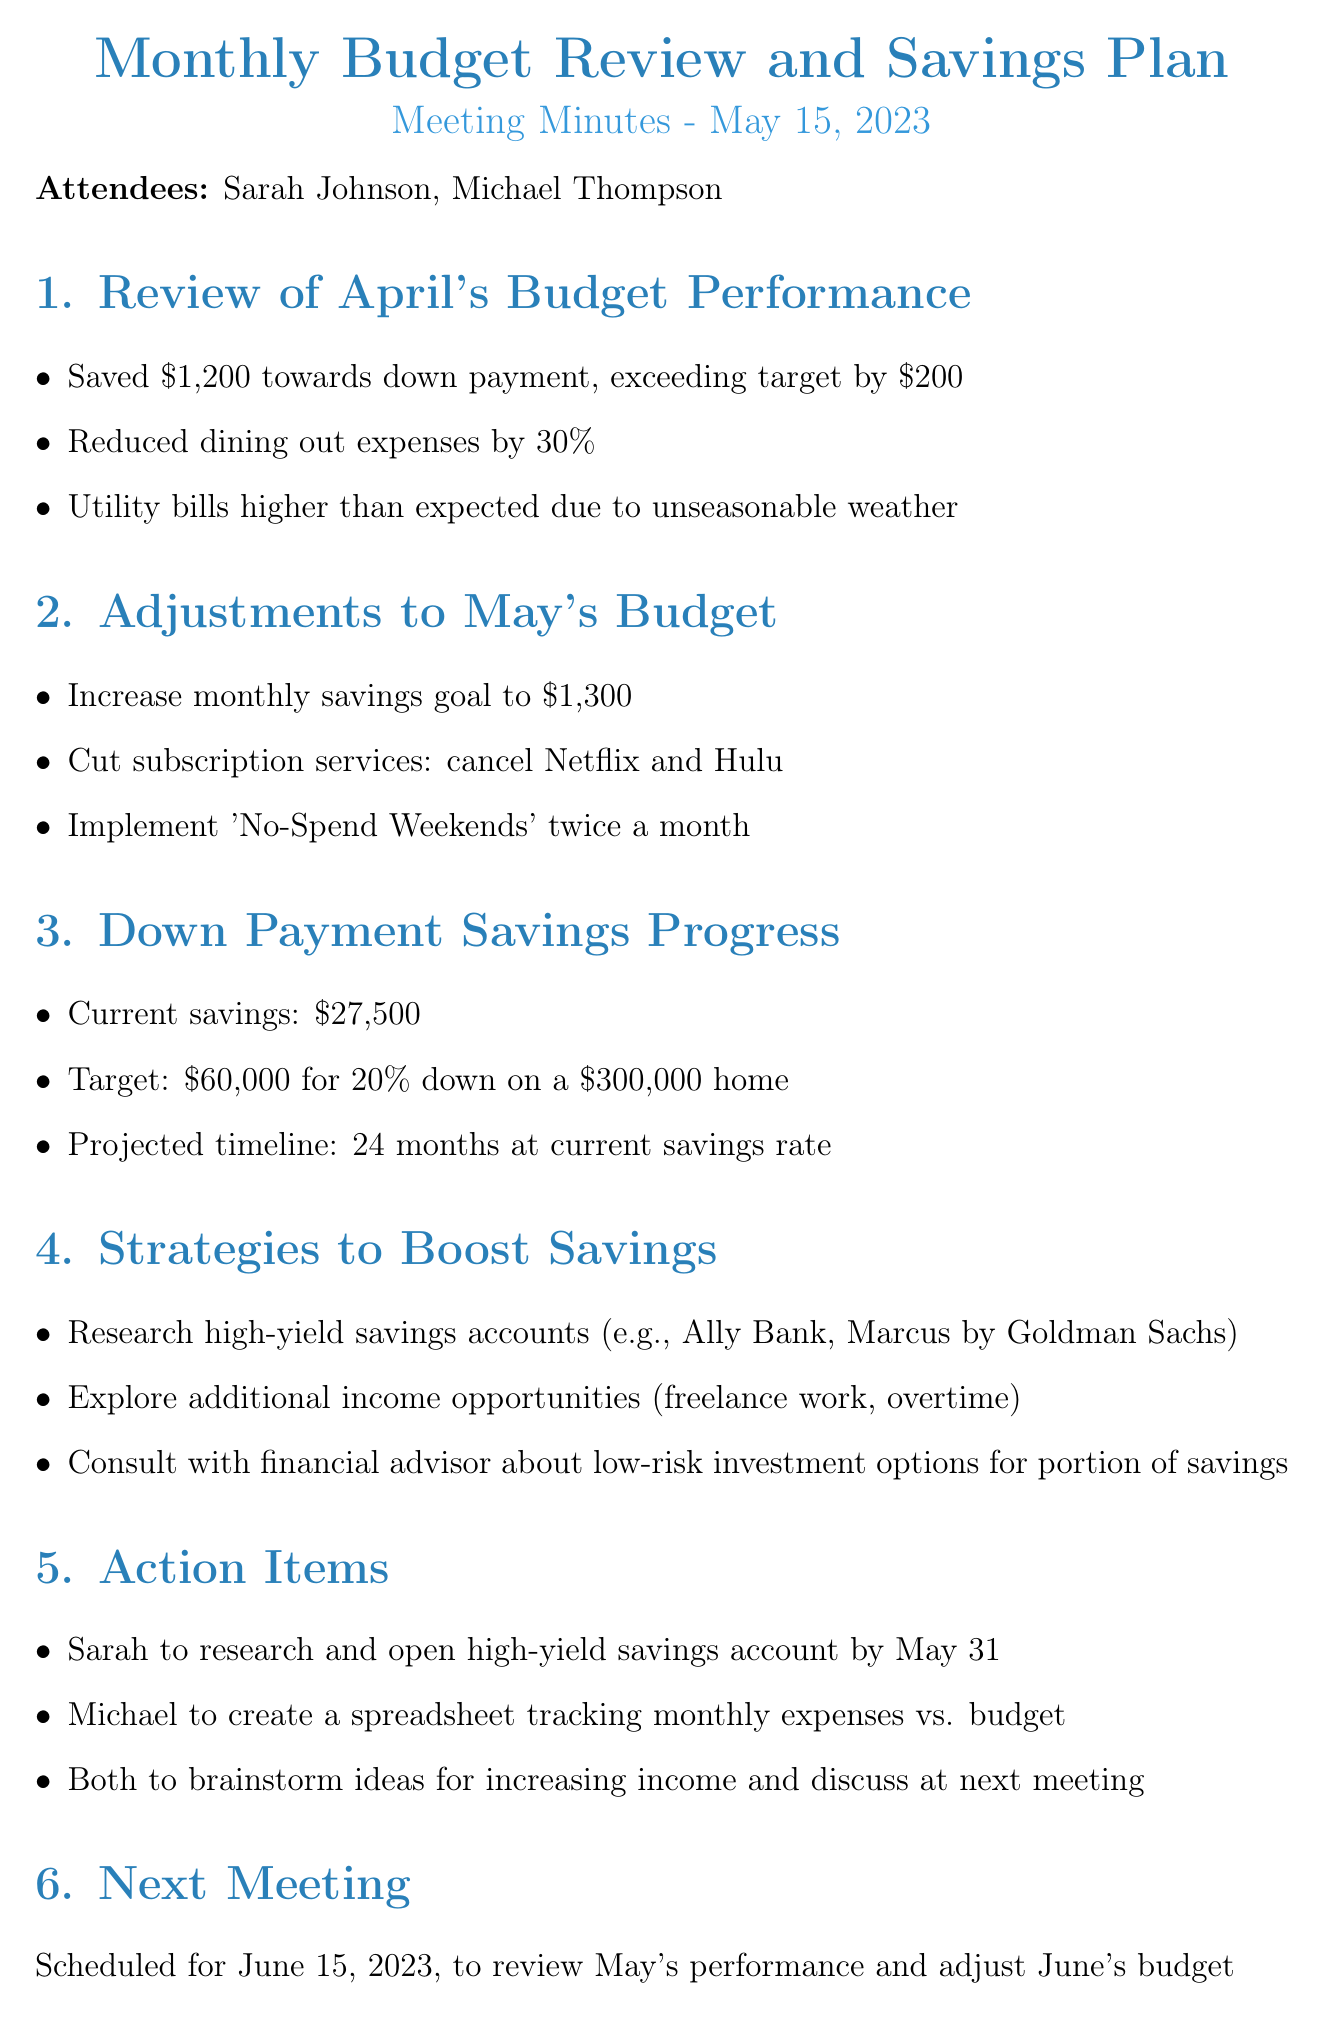What was the total amount saved towards the down payment in April? The amount saved towards the down payment in April was $1,200.
Answer: $1,200 What subscription services were cut in May? The subscription services that were cut were Netflix and Hulu.
Answer: Netflix and Hulu What is the current total savings amount? The current total savings amount is $27,500.
Answer: $27,500 What is the savings goal for May? The savings goal for May was increased to $1,300.
Answer: $1,300 In how many months can they reach their target savings at the current rate? They can reach their target savings in 24 months at the current savings rate.
Answer: 24 months What action item is assigned to Sarah? Sarah is to research and open a high-yield savings account by May 31.
Answer: Research and open high-yield savings account by May 31 When is the next meeting scheduled? The next meeting is scheduled for June 15, 2023.
Answer: June 15, 2023 Which financial institution is suggested for high-yield savings accounts? Ally Bank and Marcus by Goldman Sachs are suggested for high-yield savings accounts.
Answer: Ally Bank, Marcus by Goldman Sachs What percentage was the reduction in dining out expenses? The reduction in dining out expenses was 30%.
Answer: 30% 